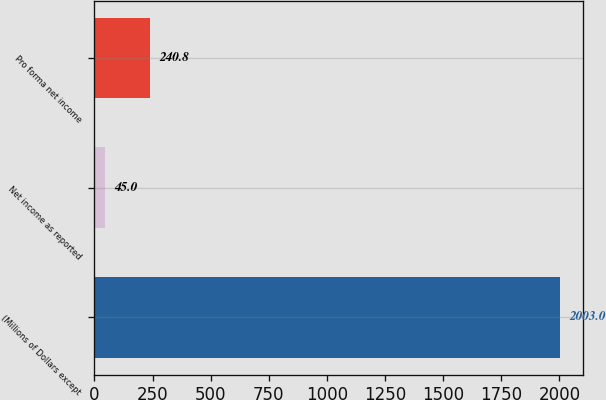Convert chart. <chart><loc_0><loc_0><loc_500><loc_500><bar_chart><fcel>(Millions of Dollars except<fcel>Net income as reported<fcel>Pro forma net income<nl><fcel>2003<fcel>45<fcel>240.8<nl></chart> 